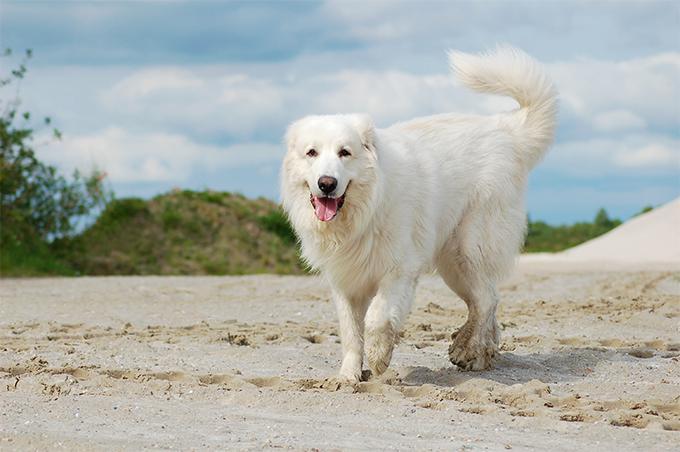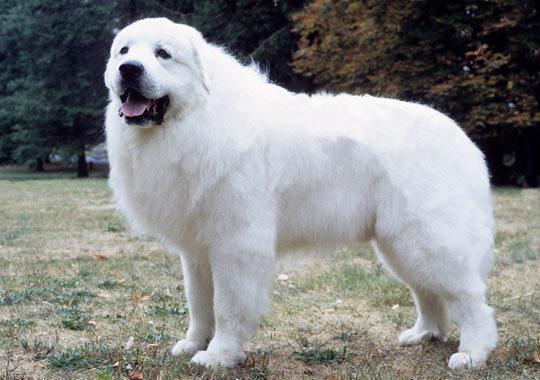The first image is the image on the left, the second image is the image on the right. Assess this claim about the two images: "A dog is lying on all fours with its head up in the air.". Correct or not? Answer yes or no. No. The first image is the image on the left, the second image is the image on the right. Examine the images to the left and right. Is the description "An image shows a white dog standing still, its body in profile." accurate? Answer yes or no. Yes. The first image is the image on the left, the second image is the image on the right. For the images shown, is this caption "There are more than two dogs" true? Answer yes or no. No. The first image is the image on the left, the second image is the image on the right. For the images shown, is this caption "There are three dogs." true? Answer yes or no. No. 